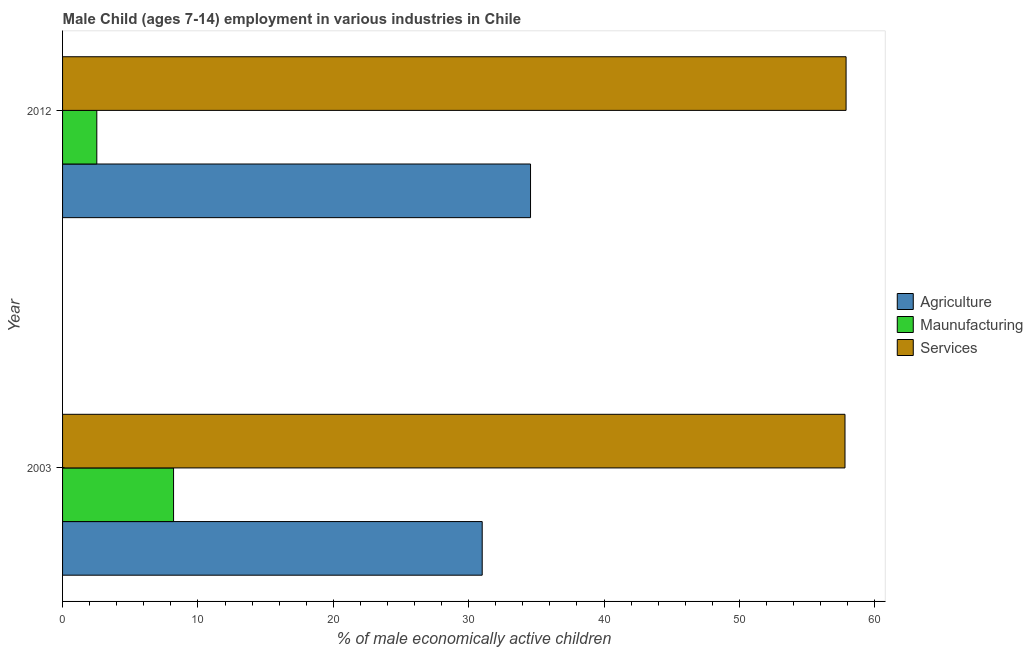How many different coloured bars are there?
Offer a terse response. 3. How many groups of bars are there?
Offer a very short reply. 2. Are the number of bars per tick equal to the number of legend labels?
Your answer should be very brief. Yes. In how many cases, is the number of bars for a given year not equal to the number of legend labels?
Your response must be concise. 0. What is the percentage of economically active children in agriculture in 2003?
Provide a short and direct response. 31. Across all years, what is the maximum percentage of economically active children in agriculture?
Your response must be concise. 34.57. Across all years, what is the minimum percentage of economically active children in manufacturing?
Offer a terse response. 2.53. In which year was the percentage of economically active children in services maximum?
Your answer should be very brief. 2012. In which year was the percentage of economically active children in manufacturing minimum?
Offer a very short reply. 2012. What is the total percentage of economically active children in agriculture in the graph?
Your response must be concise. 65.57. What is the difference between the percentage of economically active children in manufacturing in 2003 and that in 2012?
Your response must be concise. 5.67. What is the difference between the percentage of economically active children in manufacturing in 2003 and the percentage of economically active children in agriculture in 2012?
Provide a short and direct response. -26.37. What is the average percentage of economically active children in manufacturing per year?
Provide a succinct answer. 5.37. In the year 2003, what is the difference between the percentage of economically active children in agriculture and percentage of economically active children in services?
Provide a short and direct response. -26.8. In how many years, is the percentage of economically active children in agriculture greater than 20 %?
Make the answer very short. 2. What is the ratio of the percentage of economically active children in services in 2003 to that in 2012?
Provide a succinct answer. 1. Is the percentage of economically active children in manufacturing in 2003 less than that in 2012?
Provide a succinct answer. No. Is the difference between the percentage of economically active children in manufacturing in 2003 and 2012 greater than the difference between the percentage of economically active children in agriculture in 2003 and 2012?
Provide a short and direct response. Yes. What does the 3rd bar from the top in 2003 represents?
Your response must be concise. Agriculture. What does the 1st bar from the bottom in 2003 represents?
Offer a terse response. Agriculture. How many years are there in the graph?
Keep it short and to the point. 2. Are the values on the major ticks of X-axis written in scientific E-notation?
Make the answer very short. No. Does the graph contain any zero values?
Offer a terse response. No. Where does the legend appear in the graph?
Your response must be concise. Center right. What is the title of the graph?
Ensure brevity in your answer.  Male Child (ages 7-14) employment in various industries in Chile. What is the label or title of the X-axis?
Your answer should be compact. % of male economically active children. What is the label or title of the Y-axis?
Make the answer very short. Year. What is the % of male economically active children in Services in 2003?
Your answer should be very brief. 57.8. What is the % of male economically active children of Agriculture in 2012?
Offer a terse response. 34.57. What is the % of male economically active children in Maunufacturing in 2012?
Offer a very short reply. 2.53. What is the % of male economically active children in Services in 2012?
Ensure brevity in your answer.  57.88. Across all years, what is the maximum % of male economically active children in Agriculture?
Make the answer very short. 34.57. Across all years, what is the maximum % of male economically active children of Services?
Provide a succinct answer. 57.88. Across all years, what is the minimum % of male economically active children in Maunufacturing?
Ensure brevity in your answer.  2.53. Across all years, what is the minimum % of male economically active children in Services?
Provide a succinct answer. 57.8. What is the total % of male economically active children of Agriculture in the graph?
Give a very brief answer. 65.57. What is the total % of male economically active children in Maunufacturing in the graph?
Provide a succinct answer. 10.73. What is the total % of male economically active children in Services in the graph?
Make the answer very short. 115.68. What is the difference between the % of male economically active children of Agriculture in 2003 and that in 2012?
Provide a short and direct response. -3.57. What is the difference between the % of male economically active children in Maunufacturing in 2003 and that in 2012?
Provide a short and direct response. 5.67. What is the difference between the % of male economically active children of Services in 2003 and that in 2012?
Offer a very short reply. -0.08. What is the difference between the % of male economically active children of Agriculture in 2003 and the % of male economically active children of Maunufacturing in 2012?
Ensure brevity in your answer.  28.47. What is the difference between the % of male economically active children in Agriculture in 2003 and the % of male economically active children in Services in 2012?
Give a very brief answer. -26.88. What is the difference between the % of male economically active children of Maunufacturing in 2003 and the % of male economically active children of Services in 2012?
Offer a terse response. -49.68. What is the average % of male economically active children in Agriculture per year?
Offer a terse response. 32.78. What is the average % of male economically active children in Maunufacturing per year?
Ensure brevity in your answer.  5.37. What is the average % of male economically active children of Services per year?
Your answer should be very brief. 57.84. In the year 2003, what is the difference between the % of male economically active children in Agriculture and % of male economically active children in Maunufacturing?
Keep it short and to the point. 22.8. In the year 2003, what is the difference between the % of male economically active children of Agriculture and % of male economically active children of Services?
Your answer should be very brief. -26.8. In the year 2003, what is the difference between the % of male economically active children in Maunufacturing and % of male economically active children in Services?
Your answer should be compact. -49.6. In the year 2012, what is the difference between the % of male economically active children of Agriculture and % of male economically active children of Maunufacturing?
Make the answer very short. 32.04. In the year 2012, what is the difference between the % of male economically active children of Agriculture and % of male economically active children of Services?
Your answer should be compact. -23.31. In the year 2012, what is the difference between the % of male economically active children in Maunufacturing and % of male economically active children in Services?
Ensure brevity in your answer.  -55.35. What is the ratio of the % of male economically active children in Agriculture in 2003 to that in 2012?
Ensure brevity in your answer.  0.9. What is the ratio of the % of male economically active children in Maunufacturing in 2003 to that in 2012?
Offer a terse response. 3.24. What is the ratio of the % of male economically active children of Services in 2003 to that in 2012?
Keep it short and to the point. 1. What is the difference between the highest and the second highest % of male economically active children of Agriculture?
Keep it short and to the point. 3.57. What is the difference between the highest and the second highest % of male economically active children in Maunufacturing?
Make the answer very short. 5.67. What is the difference between the highest and the lowest % of male economically active children in Agriculture?
Offer a very short reply. 3.57. What is the difference between the highest and the lowest % of male economically active children in Maunufacturing?
Your answer should be compact. 5.67. 